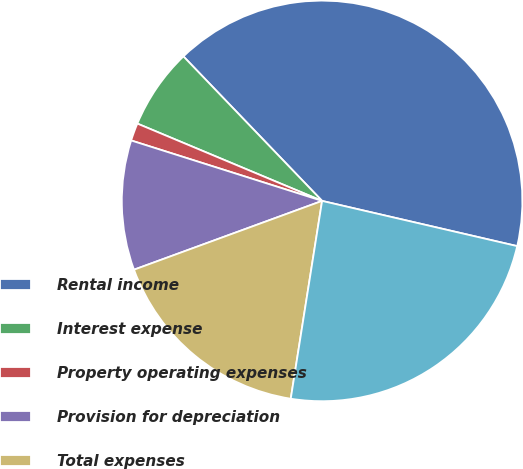Convert chart. <chart><loc_0><loc_0><loc_500><loc_500><pie_chart><fcel>Rental income<fcel>Interest expense<fcel>Property operating expenses<fcel>Provision for depreciation<fcel>Total expenses<fcel>Income (loss) from real estate<nl><fcel>40.8%<fcel>6.52%<fcel>1.43%<fcel>10.46%<fcel>16.92%<fcel>23.88%<nl></chart> 